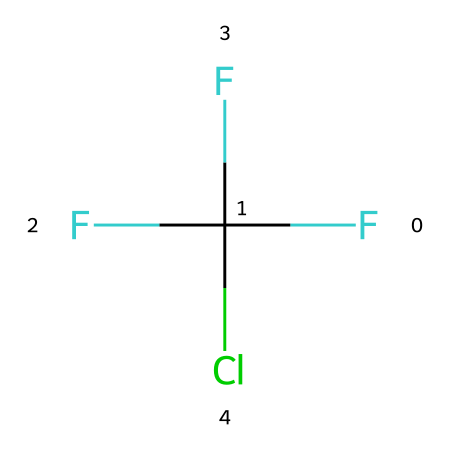What is the name of this chemical? This chemical structure corresponds to chlorofluorocarbon, as indicated by the presence of carbon (C), fluorine (F), and chlorine (Cl) atoms. This specific structure is commonly recognized in the context of refrigerants.
Answer: chlorofluorocarbon How many fluorine atoms are present? By analyzing the SMILES notation, there are three "F" symbols, indicating three fluorine atoms in the structure.
Answer: three What is the total number of hydrogen atoms? The SMILES representation shows no hydrogen atoms (indicated by the absence of any "H" in the structure), thus there are zero hydrogen atoms connected to the carbon.
Answer: zero Which element in the structure is responsible for its ozone-depleting potential? The presence of chlorine (Cl) is critical as it is notorious for its ability to deplete the ozone layer. Chlorine can catalytically break down ozone molecules in the stratosphere.
Answer: chlorine What type of bonds are present in this chemical? The structure consists of covalent bonds between the carbon atom and the attached fluorine and chlorine atoms, characteristic of organic compounds such as chlorofluorocarbons.
Answer: covalent How many carbon atoms are in the structure? The structure includes one "C" symbol in the SMILES, indicating that there is a single carbon atom present in the chemical.
Answer: one Is this chemical considered environmentally friendly? Chlorofluorocarbons are not considered environmentally friendly due to their potential for ozone layer depletion and contribution to climate change.
Answer: no 